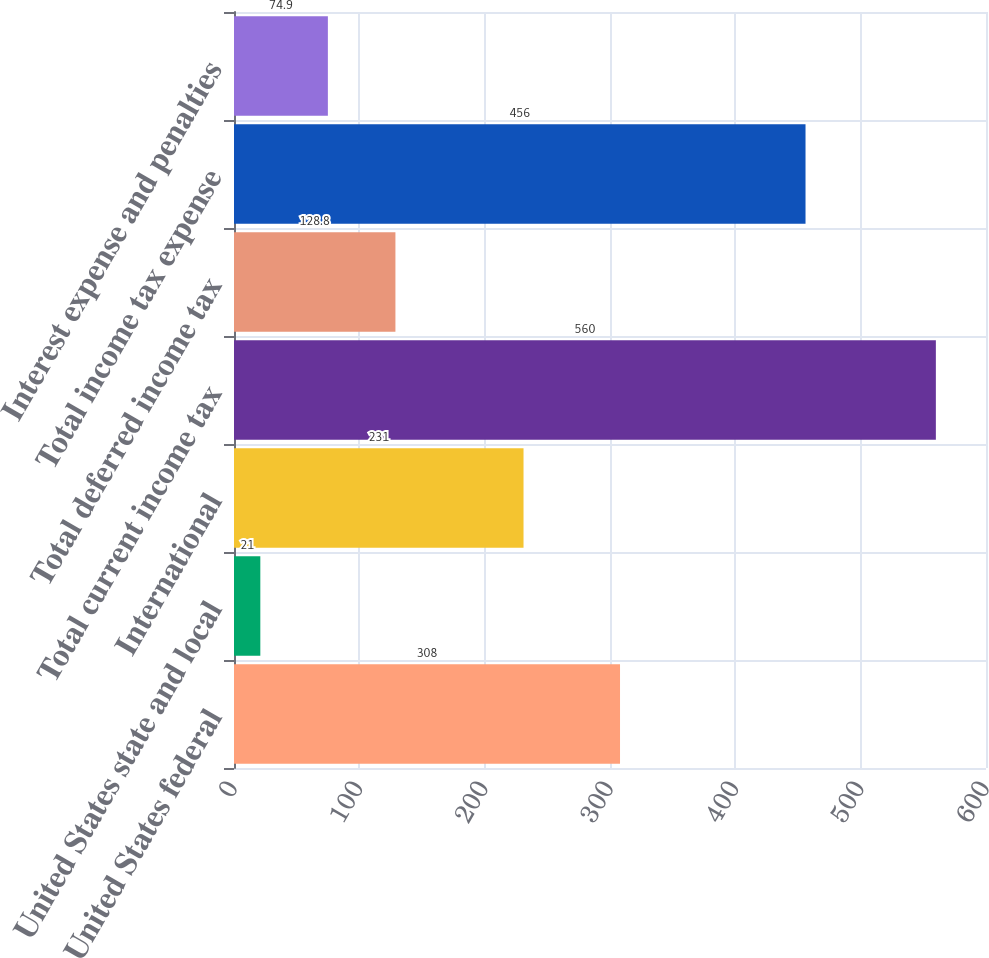Convert chart to OTSL. <chart><loc_0><loc_0><loc_500><loc_500><bar_chart><fcel>United States federal<fcel>United States state and local<fcel>International<fcel>Total current income tax<fcel>Total deferred income tax<fcel>Total income tax expense<fcel>Interest expense and penalties<nl><fcel>308<fcel>21<fcel>231<fcel>560<fcel>128.8<fcel>456<fcel>74.9<nl></chart> 